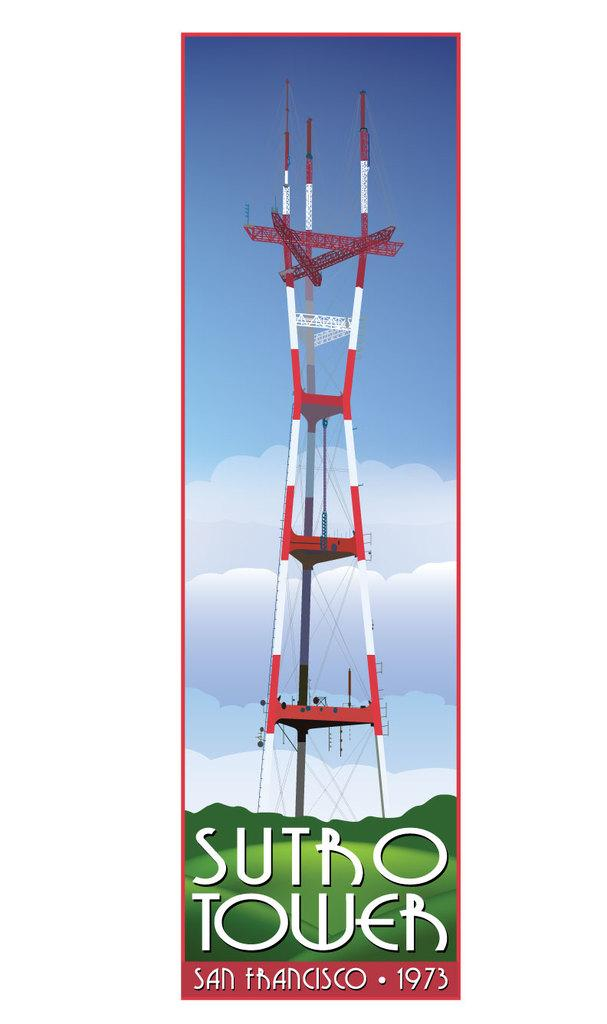<image>
Write a terse but informative summary of the picture. a sutro tower image that is of San Francisco from 1973 